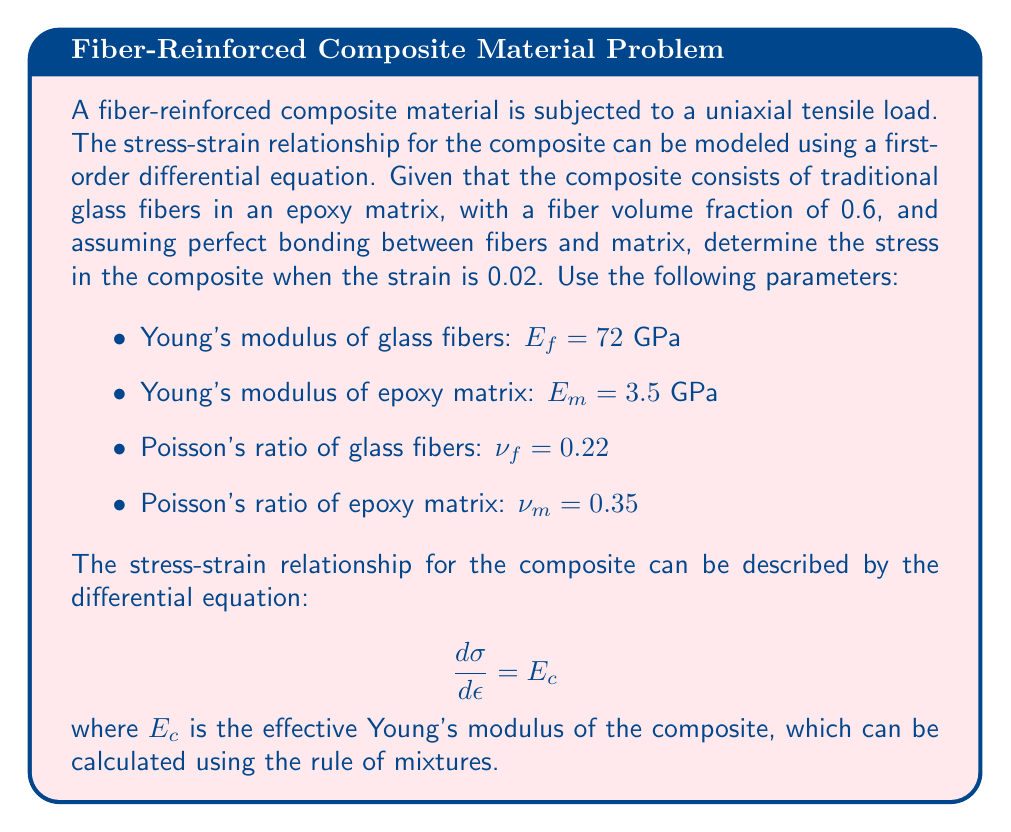What is the answer to this math problem? To solve this problem, we need to follow these steps:

1. Calculate the effective Young's modulus of the composite using the rule of mixtures.
2. Set up the differential equation for the stress-strain relationship.
3. Solve the differential equation to find the stress-strain function.
4. Calculate the stress at the given strain value.

Step 1: Calculate the effective Young's modulus

The rule of mixtures for a unidirectional fiber-reinforced composite is:

$$E_c = V_f E_f + (1 - V_f) E_m$$

where $V_f$ is the fiber volume fraction, $E_f$ is the Young's modulus of the fibers, and $E_m$ is the Young's modulus of the matrix.

Substituting the given values:

$$E_c = 0.6 \cdot 72 \text{ GPa} + (1 - 0.6) \cdot 3.5 \text{ GPa}$$
$$E_c = 43.2 \text{ GPa} + 1.4 \text{ GPa} = 44.6 \text{ GPa}$$

Step 2: Set up the differential equation

The stress-strain relationship is given by:

$$\frac{d\sigma}{d\epsilon} = E_c = 44.6 \text{ GPa}$$

Step 3: Solve the differential equation

Integrating both sides with respect to $\epsilon$:

$$\int d\sigma = \int 44.6 \text{ GPa} \, d\epsilon$$
$$\sigma = 44.6 \text{ GPa} \cdot \epsilon + C$$

Where $C$ is the constant of integration. Assuming no initial stress (i.e., $\sigma = 0$ when $\epsilon = 0$), we can determine that $C = 0$.

Therefore, the stress-strain function is:

$$\sigma = 44.6 \text{ GPa} \cdot \epsilon$$

Step 4: Calculate the stress at the given strain

For $\epsilon = 0.02$, we can calculate the stress:

$$\sigma = 44.6 \text{ GPa} \cdot 0.02 = 0.892 \text{ GPa} = 892 \text{ MPa}$$
Answer: The stress in the composite when the strain is 0.02 is 892 MPa. 